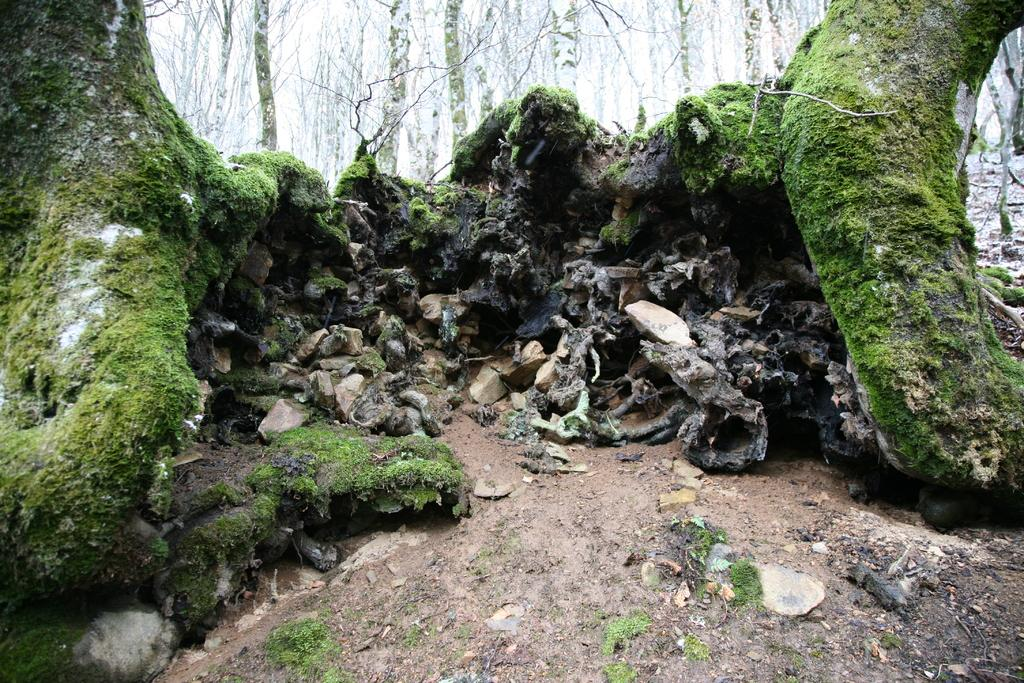What type of vegetation is growing on the rocks in the image? There is algae on the rocks in the image. What can be seen in the background of the image? There are trees in the background of the image. What type of sack is hanging from the trees in the image? There is no sack present in the image; it only features algae on the rocks and trees in the background. 